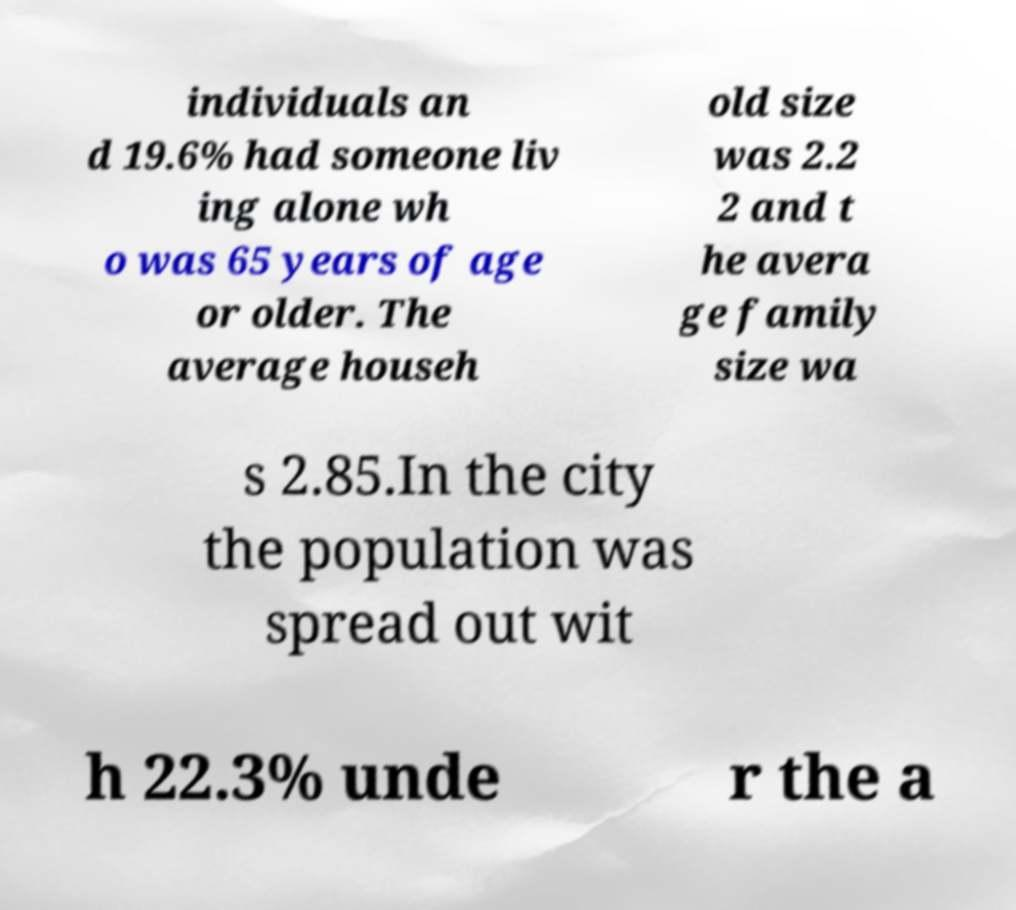Could you extract and type out the text from this image? individuals an d 19.6% had someone liv ing alone wh o was 65 years of age or older. The average househ old size was 2.2 2 and t he avera ge family size wa s 2.85.In the city the population was spread out wit h 22.3% unde r the a 